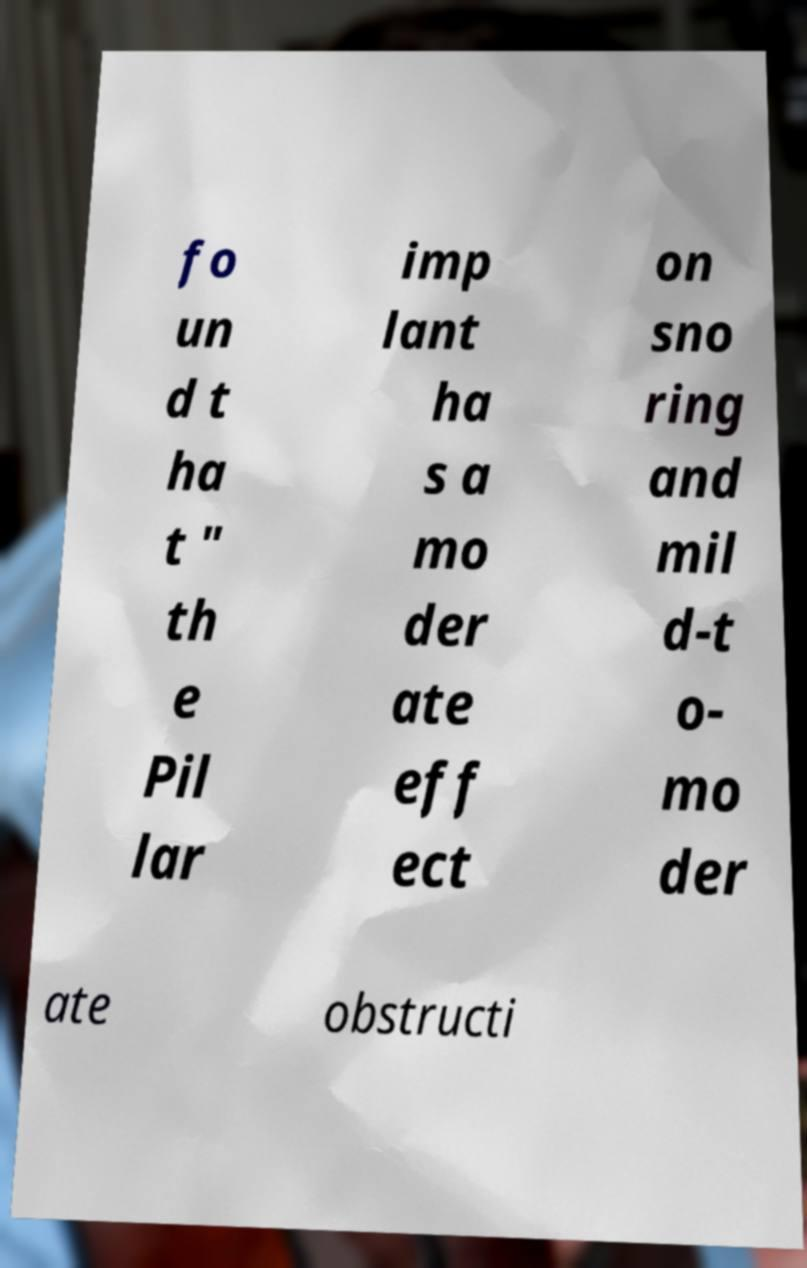Please read and relay the text visible in this image. What does it say? fo un d t ha t " th e Pil lar imp lant ha s a mo der ate eff ect on sno ring and mil d-t o- mo der ate obstructi 